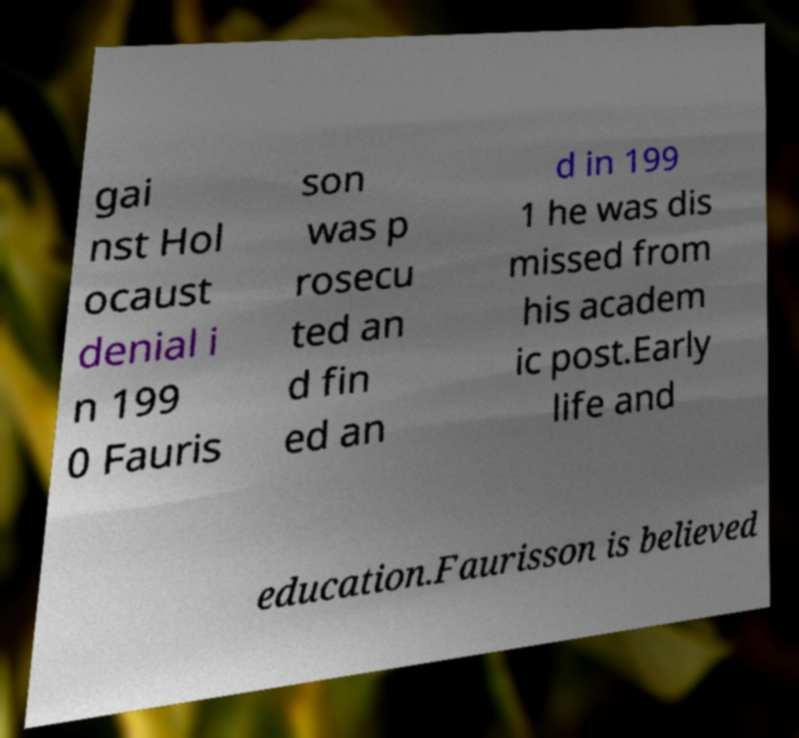For documentation purposes, I need the text within this image transcribed. Could you provide that? gai nst Hol ocaust denial i n 199 0 Fauris son was p rosecu ted an d fin ed an d in 199 1 he was dis missed from his academ ic post.Early life and education.Faurisson is believed 